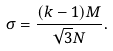Convert formula to latex. <formula><loc_0><loc_0><loc_500><loc_500>\sigma = \frac { ( k - 1 ) M } { \sqrt { 3 } N } .</formula> 